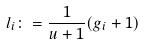<formula> <loc_0><loc_0><loc_500><loc_500>l _ { i } \colon = \frac { 1 } { u + 1 } ( g _ { i } + 1 )</formula> 